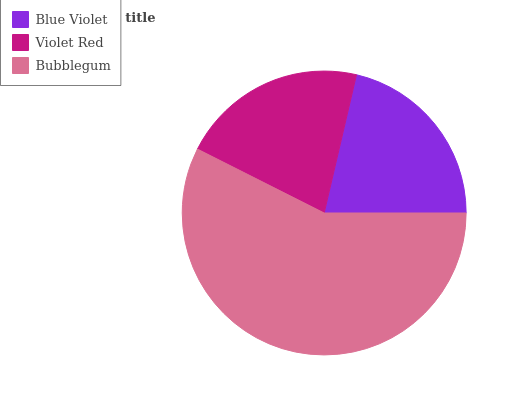Is Violet Red the minimum?
Answer yes or no. Yes. Is Bubblegum the maximum?
Answer yes or no. Yes. Is Bubblegum the minimum?
Answer yes or no. No. Is Violet Red the maximum?
Answer yes or no. No. Is Bubblegum greater than Violet Red?
Answer yes or no. Yes. Is Violet Red less than Bubblegum?
Answer yes or no. Yes. Is Violet Red greater than Bubblegum?
Answer yes or no. No. Is Bubblegum less than Violet Red?
Answer yes or no. No. Is Blue Violet the high median?
Answer yes or no. Yes. Is Blue Violet the low median?
Answer yes or no. Yes. Is Bubblegum the high median?
Answer yes or no. No. Is Bubblegum the low median?
Answer yes or no. No. 